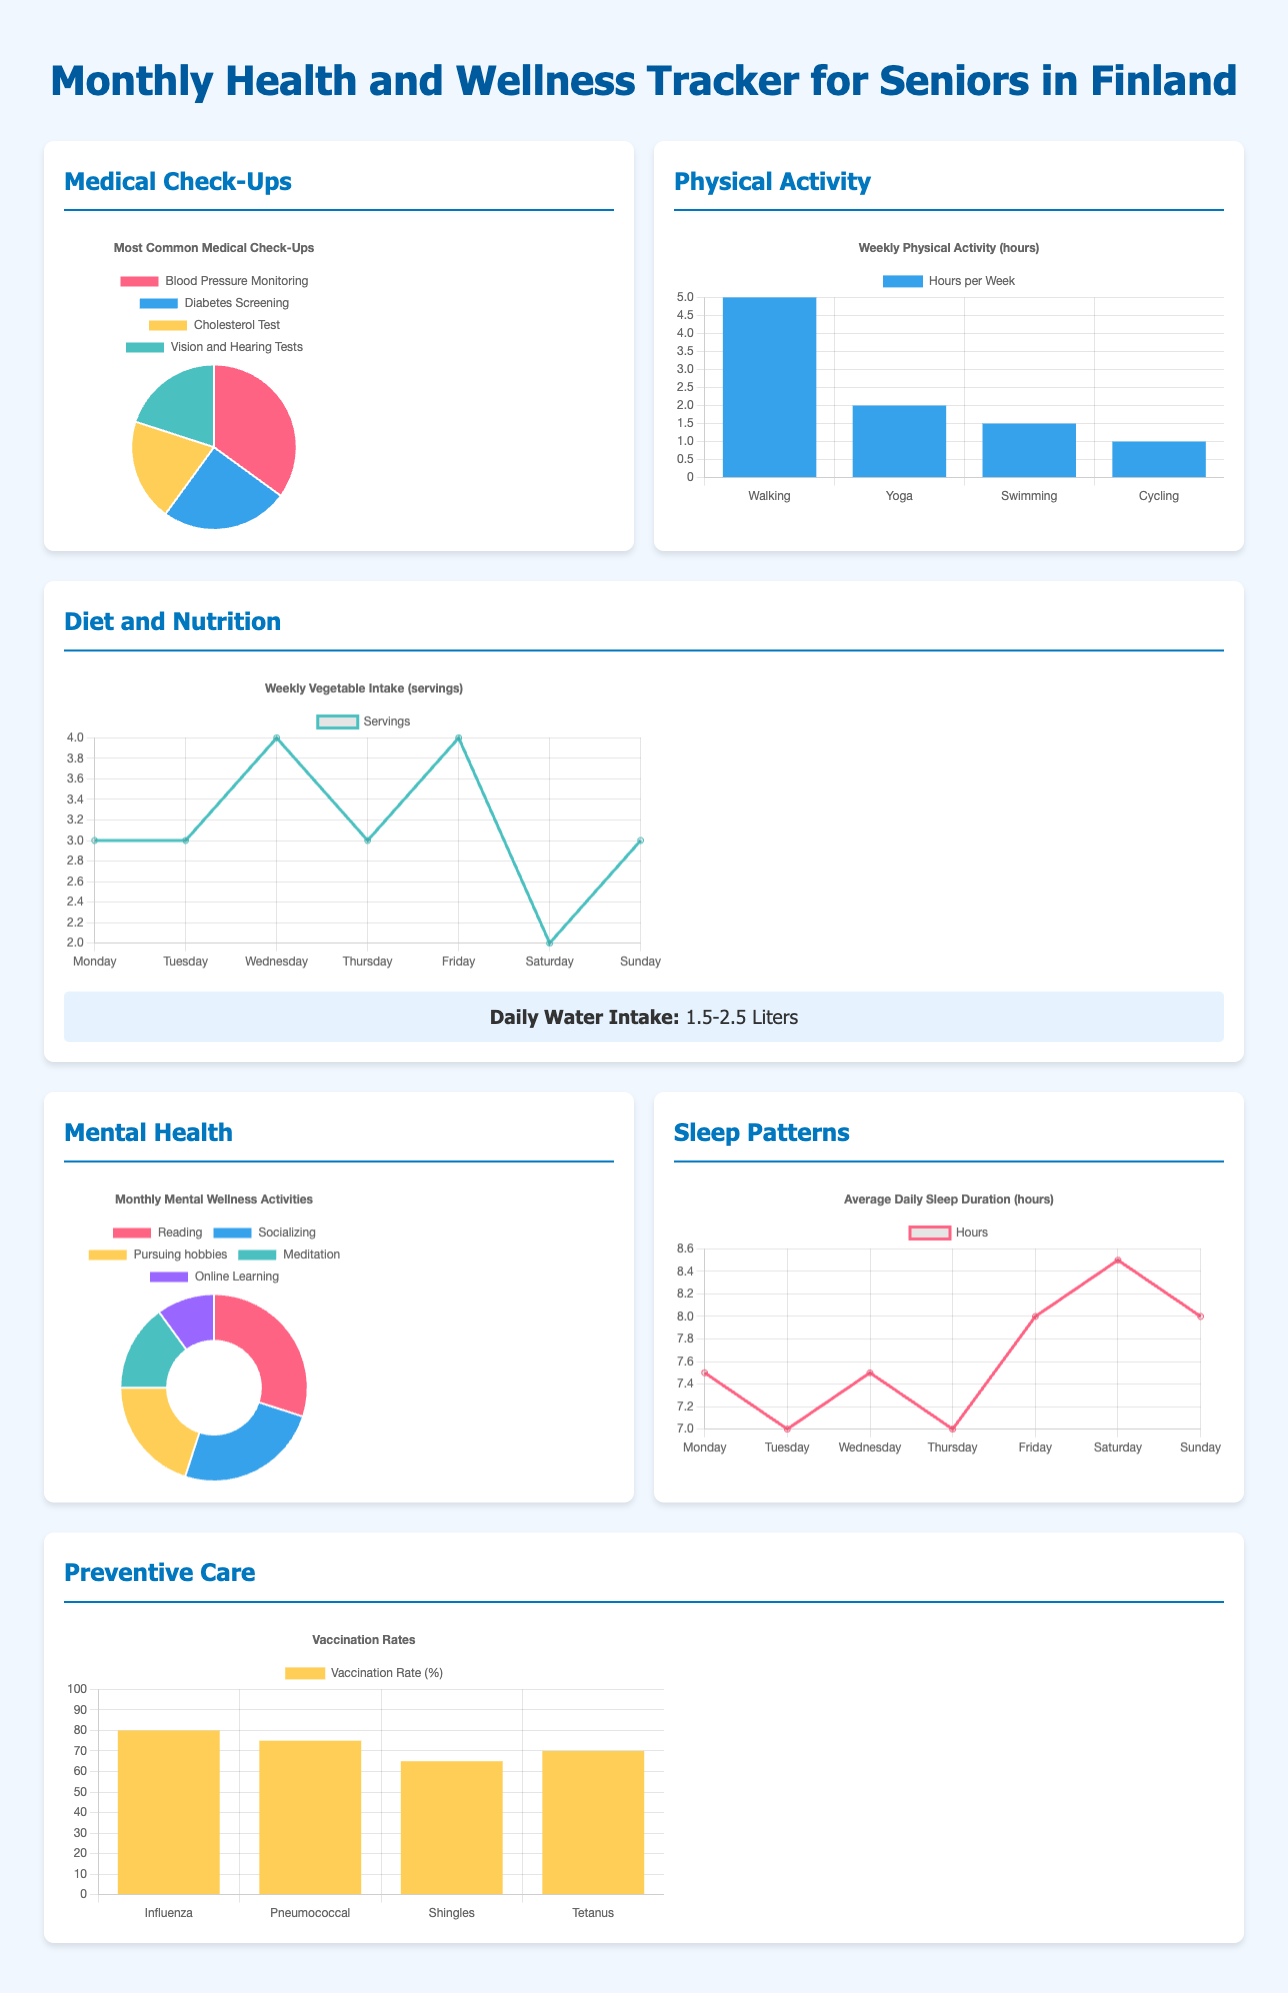What is the most common medical check-up? The most common medical check-up shown in the pie chart is Blood Pressure Monitoring, which has the largest section.
Answer: Blood Pressure Monitoring How many hours per week do seniors spend on walking? The bar chart indicates that seniors spend 5 hours per week walking.
Answer: 5 hours What is the daily water intake recommendation? The infographic specifies that the recommended daily water intake is between 1.5 to 2.5 liters.
Answer: 1.5-2.5 Liters Which mental wellness activity has the highest percentage? The doughnut chart indicates that Reading occupies the largest percentage of mental wellness activities.
Answer: Reading What is the vaccination rate for Pneumococcal? The bar chart shows that the vaccination rate for Pneumococcal is 75%.
Answer: 75% Overall, which physical activity has the least time? In the physical activity chart, Cycling is listed as the least time-consuming activity with only 1 hour per week.
Answer: 1 hour How many servings of vegetables are consumed on Wednesday? The line chart shows that seniors consume 4 servings of vegetables on Wednesday.
Answer: 4 servings What is the average daily sleep duration on Saturday? The line chart displays an average daily sleep duration of 8.5 hours for Saturday.
Answer: 8.5 hours What percentage of seniors engage in meditation for mental wellness? The doughnut chart indicates that 15% of seniors engage in meditation.
Answer: 15% 